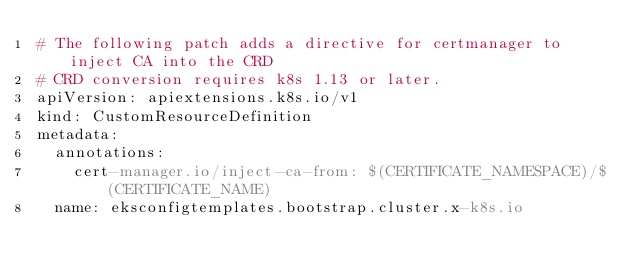Convert code to text. <code><loc_0><loc_0><loc_500><loc_500><_YAML_># The following patch adds a directive for certmanager to inject CA into the CRD
# CRD conversion requires k8s 1.13 or later.
apiVersion: apiextensions.k8s.io/v1
kind: CustomResourceDefinition
metadata:
  annotations:
    cert-manager.io/inject-ca-from: $(CERTIFICATE_NAMESPACE)/$(CERTIFICATE_NAME)
  name: eksconfigtemplates.bootstrap.cluster.x-k8s.io
</code> 